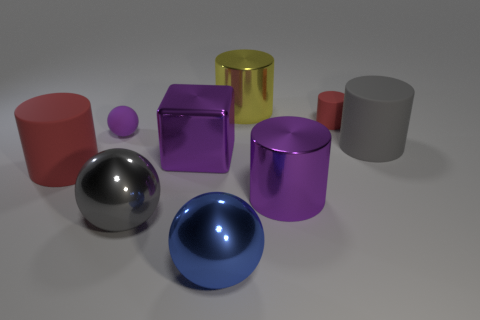There is a cylinder that is on the left side of the large blue ball; does it have the same color as the tiny cylinder?
Make the answer very short. Yes. How many other things are there of the same color as the tiny cylinder?
Provide a succinct answer. 1. How many other things are made of the same material as the tiny ball?
Provide a succinct answer. 3. What is the size of the gray thing that is the same shape as the big red object?
Offer a very short reply. Large. Is the large gray object that is on the right side of the purple metallic cylinder made of the same material as the gray object that is left of the yellow thing?
Ensure brevity in your answer.  No. Is the number of small red rubber objects in front of the tiny red cylinder less than the number of small purple cylinders?
Give a very brief answer. No. There is a small rubber object that is the same shape as the big gray shiny object; what is its color?
Your answer should be very brief. Purple. Does the metallic object behind the purple rubber ball have the same size as the tiny purple rubber ball?
Ensure brevity in your answer.  No. What size is the gray thing on the left side of the big gray object that is right of the blue thing?
Your answer should be very brief. Large. Are the purple block and the red object to the right of the tiny purple rubber sphere made of the same material?
Your response must be concise. No. 